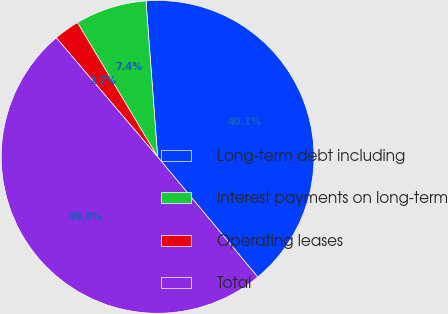Convert chart. <chart><loc_0><loc_0><loc_500><loc_500><pie_chart><fcel>Long-term debt including<fcel>Interest payments on long-term<fcel>Operating leases<fcel>Total<nl><fcel>40.13%<fcel>7.38%<fcel>2.66%<fcel>49.83%<nl></chart> 